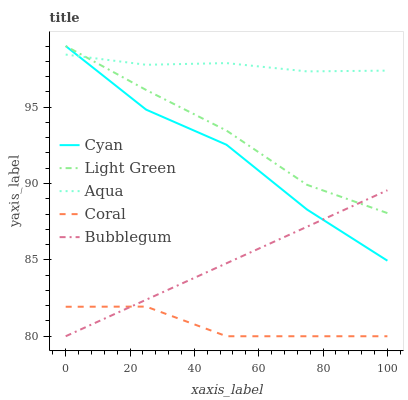Does Coral have the minimum area under the curve?
Answer yes or no. Yes. Does Aqua have the maximum area under the curve?
Answer yes or no. Yes. Does Aqua have the minimum area under the curve?
Answer yes or no. No. Does Coral have the maximum area under the curve?
Answer yes or no. No. Is Bubblegum the smoothest?
Answer yes or no. Yes. Is Cyan the roughest?
Answer yes or no. Yes. Is Coral the smoothest?
Answer yes or no. No. Is Coral the roughest?
Answer yes or no. No. Does Aqua have the lowest value?
Answer yes or no. No. Does Light Green have the highest value?
Answer yes or no. Yes. Does Aqua have the highest value?
Answer yes or no. No. Is Coral less than Light Green?
Answer yes or no. Yes. Is Aqua greater than Coral?
Answer yes or no. Yes. Does Coral intersect Light Green?
Answer yes or no. No. 